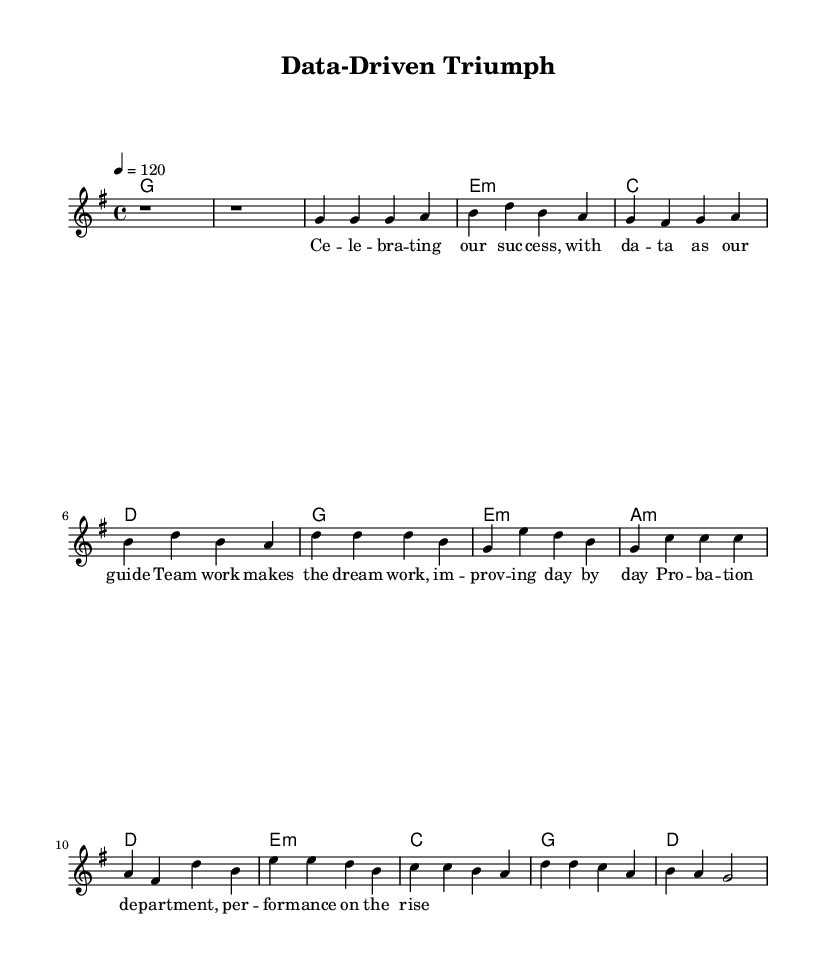What is the key signature of this music? The key signature is G major, which has one sharp (F#). From the music, we can determine it is in G major by looking for the sharp sign next to F in the staff at the start.
Answer: G major What is the time signature of this piece? The time signature is 4/4, indicated prominently at the beginning of the score right after the key signature. This means there are four beats per measure, and the quarter note receives one beat.
Answer: 4/4 What is the tempo marking for this piece? The tempo marking is 120 beats per minute, shown as "4 = 120" at the beginning of the score. This indicates how fast the piece is to be played.
Answer: 120 How many measures are there in the chorus section? There are four measures in the chorus section, which can be counted from the notation that represents the chorus in the music sheet. Each line containing the chorus lists four distinct sets of notes in measure format.
Answer: 4 What is the primary theme of the lyrics? The primary theme is celebrating teamwork and success, as indicated by phrases like "celebrating our success" and "team work makes the dream work." The lyrics explicitly connect achievements with collaboration, typical in Rhythm and Blues music.
Answer: Celebrating teamwork What chord follows the first melody note in the bridge? The chord following the first melody note in the bridge, which is E, is E minor as represented in the chord symbols under the melody notes where it states "e1:m." This indicates the harmony to be played along with the melody.
Answer: E minor How is the structure of the song organized? The structure of the song is organized into an intro, verses, a chorus, and a bridge. This classical structure allows for the repetition of themes and melodies typical in Rhythm and Blues genres, leading to a memorable and uplifting piece.
Answer: Intro, verse, chorus, bridge 